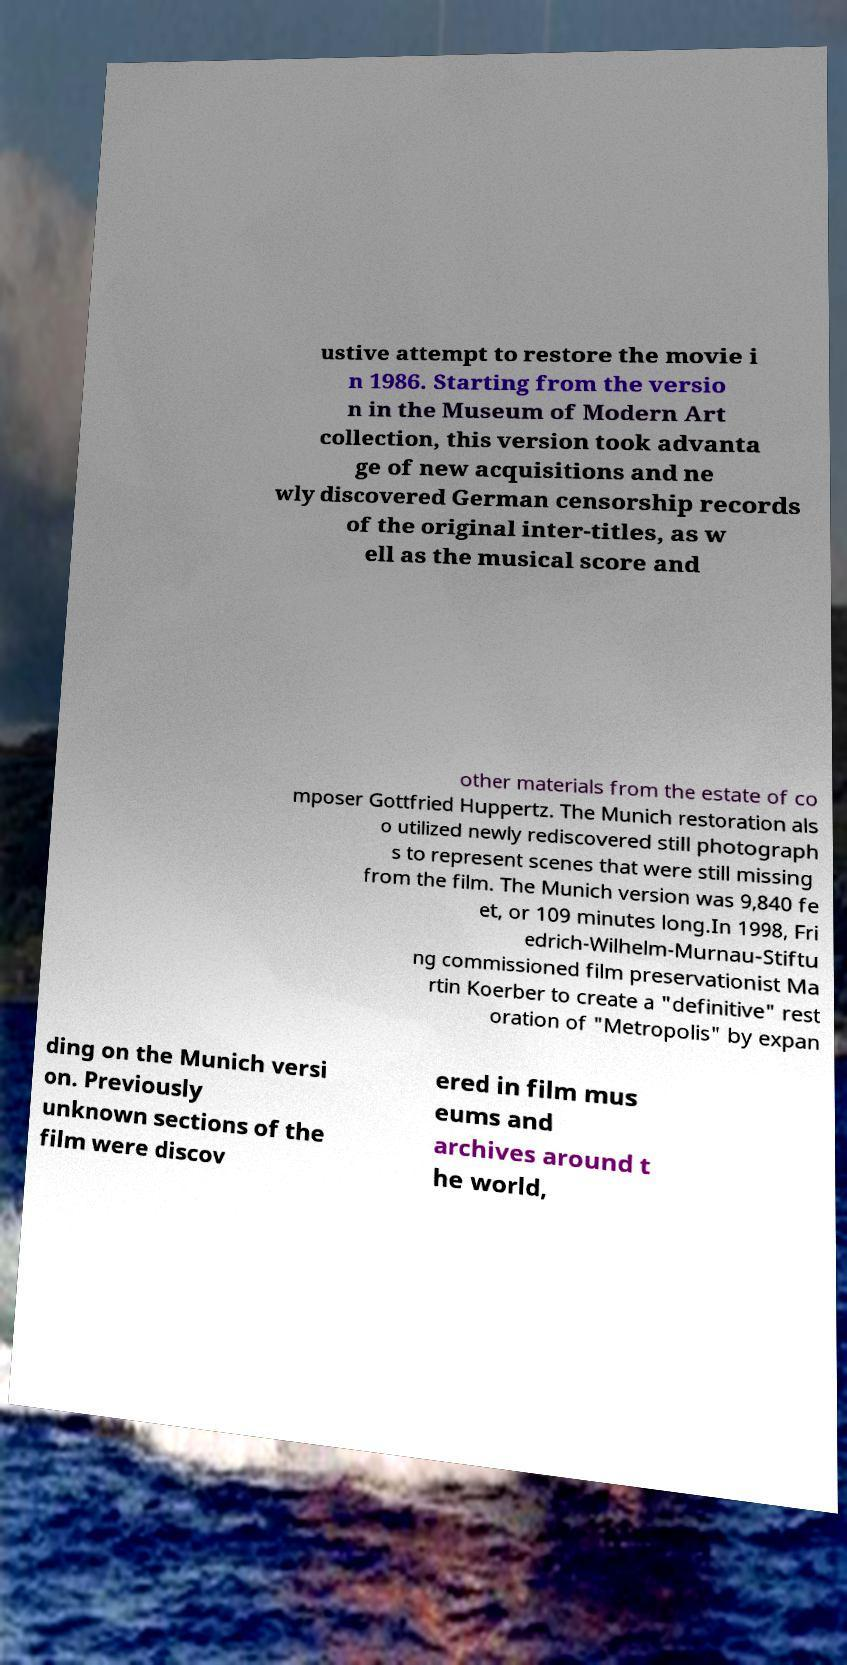Could you assist in decoding the text presented in this image and type it out clearly? ustive attempt to restore the movie i n 1986. Starting from the versio n in the Museum of Modern Art collection, this version took advanta ge of new acquisitions and ne wly discovered German censorship records of the original inter-titles, as w ell as the musical score and other materials from the estate of co mposer Gottfried Huppertz. The Munich restoration als o utilized newly rediscovered still photograph s to represent scenes that were still missing from the film. The Munich version was 9,840 fe et, or 109 minutes long.In 1998, Fri edrich-Wilhelm-Murnau-Stiftu ng commissioned film preservationist Ma rtin Koerber to create a "definitive" rest oration of "Metropolis" by expan ding on the Munich versi on. Previously unknown sections of the film were discov ered in film mus eums and archives around t he world, 